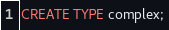Convert code to text. <code><loc_0><loc_0><loc_500><loc_500><_SQL_>CREATE TYPE complex;
</code> 